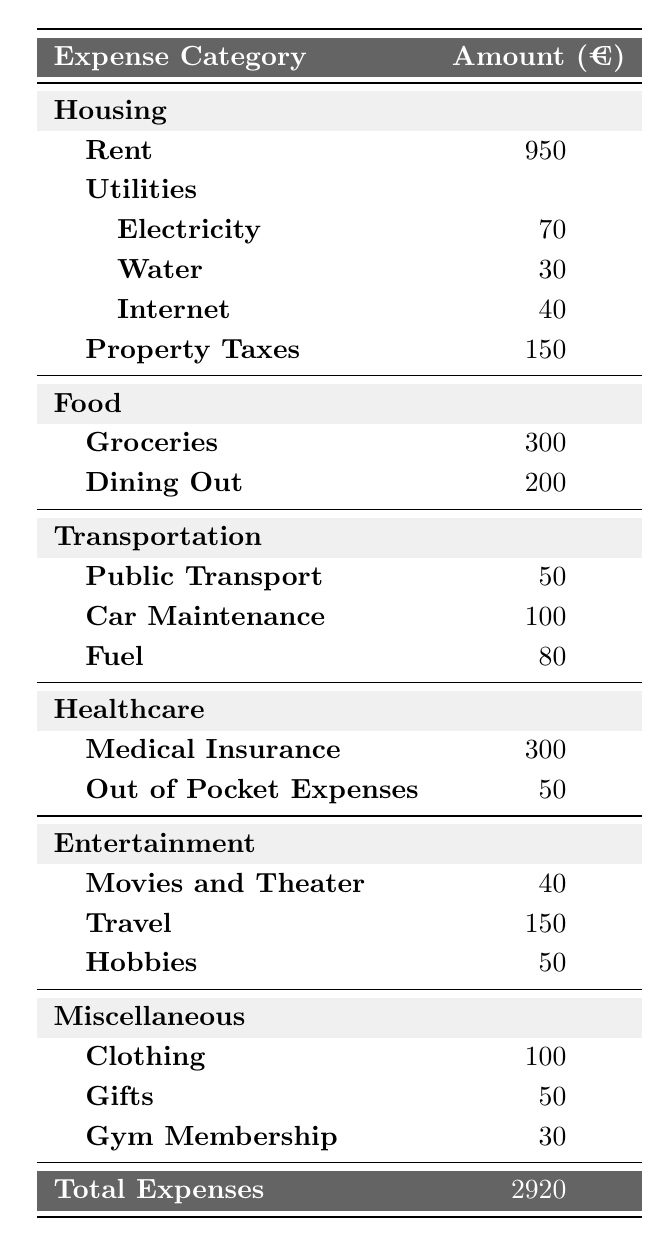What is the total amount spent on food each month? To find the total spent on food, we need to sum the amounts for Groceries and Dining Out. That’s 300 (Groceries) + 200 (Dining Out) = 500.
Answer: 500 What is the cost of Medical Insurance? The expense for Medical Insurance is listed directly in the Healthcare section of the table as 300.
Answer: 300 How much is spent on utilities in total? We add up the expenses for Electricity, Water, and Internet. So, 70 (Electricity) + 30 (Water) + 40 (Internet) = 140.
Answer: 140 Is the total amount spent on Transportation higher than the total amount spent on Healthcare? First, the total for Transportation (50 + 100 + 80 = 230) is compared to Healthcare (300 + 50 = 350). Since 230 is less than 350, the answer is no.
Answer: No What is the total expense for miscellaneous items? The total for miscellaneous is found by adding Clothing, Gifts, and Gym Membership. Therefore, 100 (Clothing) + 50 (Gifts) + 30 (Gym Membership) = 180.
Answer: 180 Which category has the highest expense? By examining each category’s total: Housing (950 + 70 + 30 + 40 + 150 = 1240), Food (500), Transportation (230), Healthcare (350), Entertainment (240), and Miscellaneous (180). Housing has the highest total of 1240.
Answer: Housing If you add the gross expenses of Food and Entertainment, what is the total? First, calculate total Food (500) and total Entertainment (240). Summing these gives us 500 + 240 = 740.
Answer: 740 What is the average amount spent on each category listed? The categories listed are 6 (Housing, Food, Transportation, Healthcare, Entertainment, Miscellaneous). The total expenses are 2920. So, 2920 divided by 6 equals approximately 486.67.
Answer: 486.67 How much more is spent on Housing than on Transportation? Housing total is 1240 and Transportation total is 230. We find the difference: 1240 - 230 = 1010.
Answer: 1010 What is the total amount of expenses for Dining Out and Travel combined? Adding Dining Out (200) and Travel (150) gives us 200 + 150 = 350.
Answer: 350 